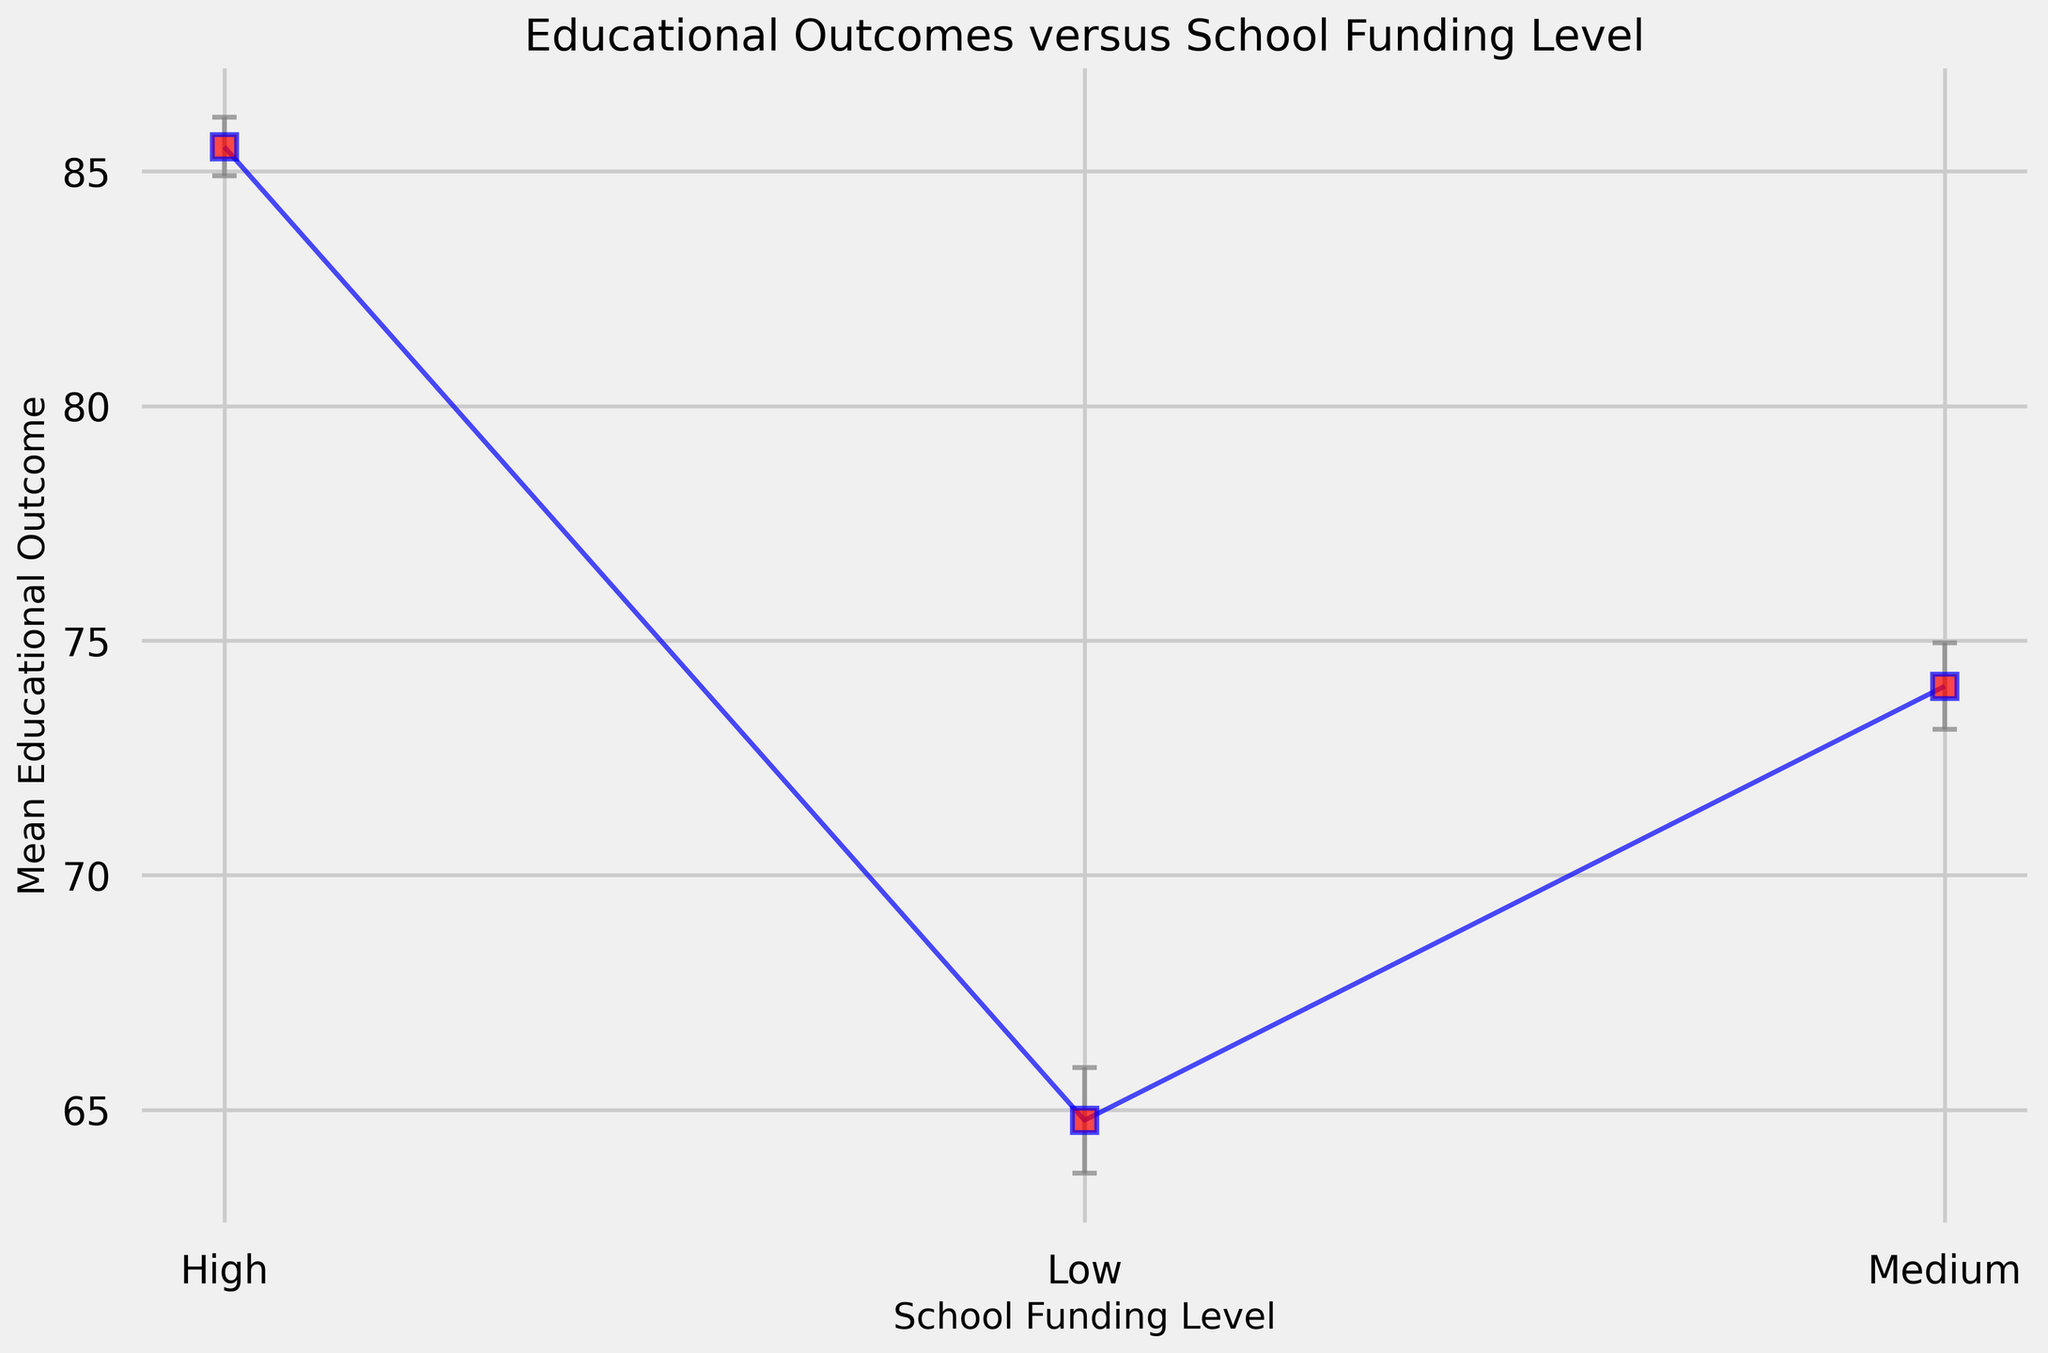What is the overall trend of educational outcomes as school funding levels increase? Observing the chart, the mean educational outcomes increase as the funding level progresses from Low to Medium to High. This can be concluded by the upward trend in the mean outcome values along with decreasing standard deviations, indicating a positive correlation between funding level and educational performance.
Answer: Mean outcomes increase with higher funding levels How do the error bars (standard deviations) vary for different funding levels? The error bars represent the variability of educational outcomes within each funding level. The chart shows that error bars are widest for low funding levels, indicating higher variability, and narrowest for high funding levels, indicating lower variability.
Answer: Error bars decrease with higher funding levels Which funding level has the highest mean educational outcome? By observing the positioning of the data points on the vertical Mean Educational Outcome axis, the High funding level has the highest mean outcome, as its mean value is notably higher than those of Medium and Low funding levels.
Answer: High funding level What is the total mean outcome for Low and Medium funding levels combined? First, we find the mean outcomes of Low and Medium levels from the chart, which are roughly 64.775 and 74.025 respectively. Summing these up: 64.775 + 74.025 = 138.8
Answer: 138.8 Comparing the standard deviation, which funding level has the highest variability in outcomes? Standard deviation is visually represented by the height of the error bars. From the chart, the Low funding level has the tallest error bars, indicating the highest standard deviation or variability in outcomes.
Answer: Low funding level Which funding level has the lowest standard deviation for educational outcomes? From the chart, the error bars for the High funding level are the shortest, indicating it has the lowest standard deviation among the three funding levels.
Answer: High funding level What is the difference in mean educational outcomes between High and Low funding levels? According to the chart, the approximate mean educational outcomes are 85.525 for High and 64.775 for Low funding levels. The difference is 85.525 - 64.775 = 20.75
Answer: 20.75 By how much does the mean outcome of the Medium funding level exceed that of the Low funding level? From the chart, the mean outcome for the Medium funding level is roughly 74.025 and for Low funding level, it is about 64.775. The difference is 74.025 - 64.775 = 9.25
Answer: 9.25 How might the narrowing error bars affect the interpretation of funding impacts? Narrower error bars in High funding levels suggest less variability and higher reliability in outcomes compared to broader error bars in Low funding levels. This implies that higher funding not only improves average outcomes but also reduces inconsistency in educational performance.
Answer: Less variability and higher reliability What visual characteristic indicates the standard deviation in the chart? The length of the error bars, extending above and below the mean values, visually represents the standard deviation. Larger bars denote higher standard deviations, while shorter bars indicate lower ones.
Answer: Length of the error bars 